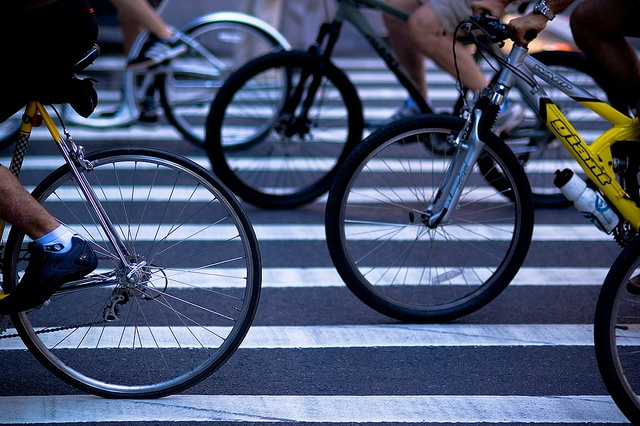Describe the objects in this image and their specific colors. I can see bicycle in black, navy, darkblue, and gray tones, bicycle in black, navy, darkblue, and lavender tones, bicycle in black, darkblue, navy, and gray tones, people in black, brown, navy, and maroon tones, and bicycle in black, gray, and blue tones in this image. 